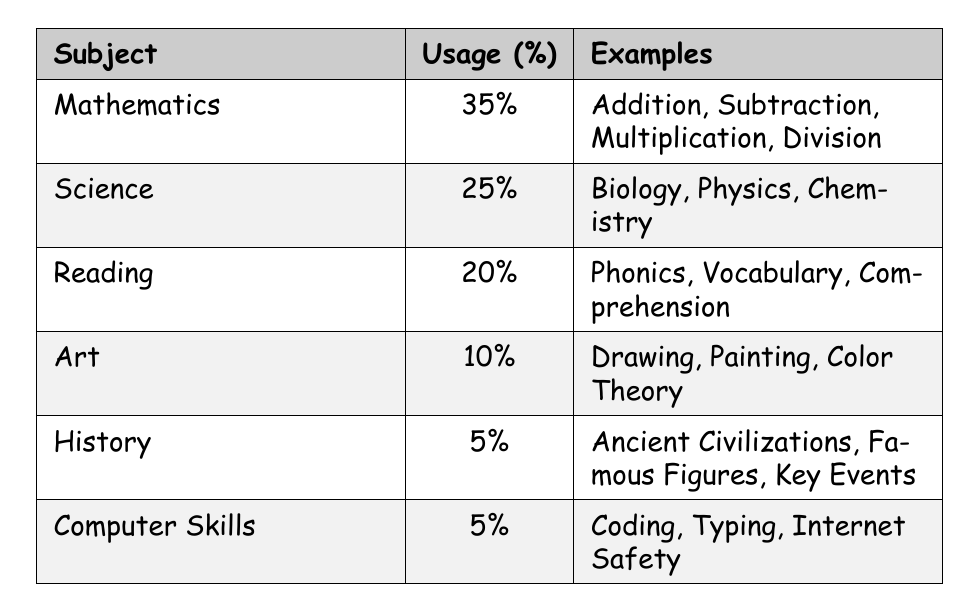What subject has the highest usage percentage? The usage percentages for each subject are listed in the table. Mathematics has the highest percentage at 35%.
Answer: Mathematics What percentage of children use Reading as a subject? The usage percentage for Reading is provided in the table, which states it is 20%.
Answer: 20% Which subjects have a usage percentage of 5%? The table lists History and Computer Skills, both with a usage percentage of 5%.
Answer: History and Computer Skills What is the total percentage of Mathematics and Science usage? To find the total percentage, add the percentages of Mathematics (35%) and Science (25%). 35 + 25 = 60.
Answer: 60% Is Art more popular than Science among children? The table shows Art with a usage percentage of 10% and Science with 25%. Since 10% is less than 25%, Art is not more popular.
Answer: No What is the difference in percentage between the most popular subject and the least popular subject? The most popular subject is Mathematics at 35%, and the least popular subjects are History and Computer Skills at 5%. The difference is calculated as 35 - 5 = 30.
Answer: 30% If a child learned only the subjects with a usage percentage of 5%, what is the total percentage for those subjects? To find the total percentage, add the percentages of History (5%) and Computer Skills (5%). So, 5 + 5 = 10.
Answer: 10% Which subject has fewer examples, Art or Science? The table lists 3 examples for Art (Drawing, Painting, Color Theory) and 3 examples for Science (Biology, Physics, Chemistry). Both have the same number of examples.
Answer: They have the same number of examples What is the average usage percentage of all subjects listed? Add all the usage percentages: 35 + 25 + 20 + 10 + 5 + 5 = 100. Then divide by the number of subjects, which is 6. So, 100 / 6 = about 16.67.
Answer: Approximately 16.67 Which subject is most related to skills like Coding and Typing? The examples listed under Computer Skills include Coding and Typing, thus it is the subject most related to these skills.
Answer: Computer Skills 